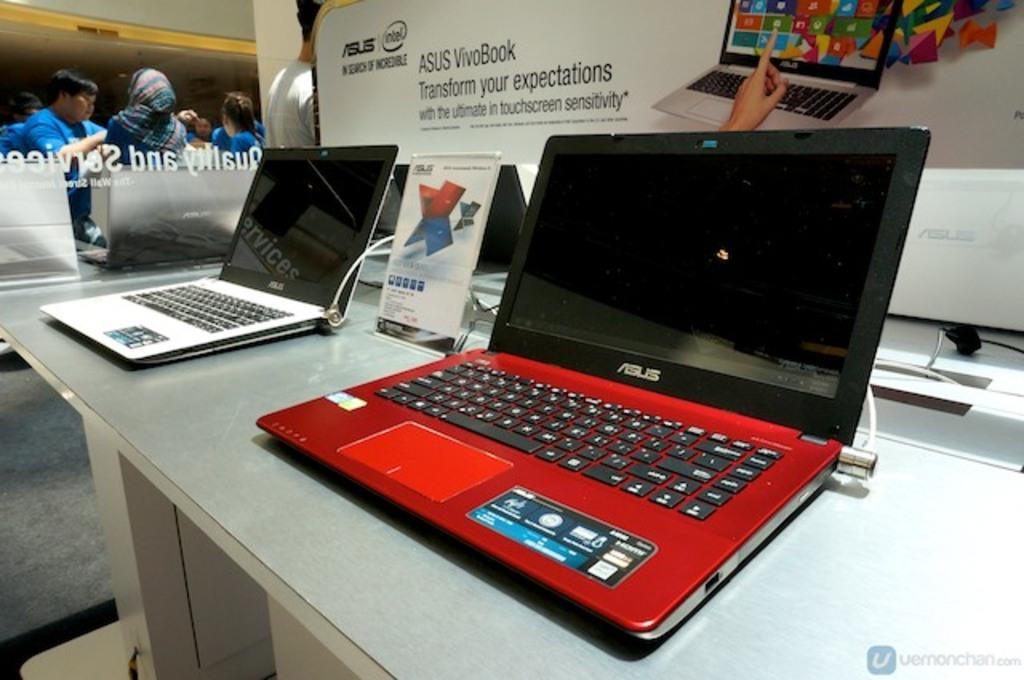<image>
Give a short and clear explanation of the subsequent image. Red and black Asus laptop on display next to a silver laptop. 